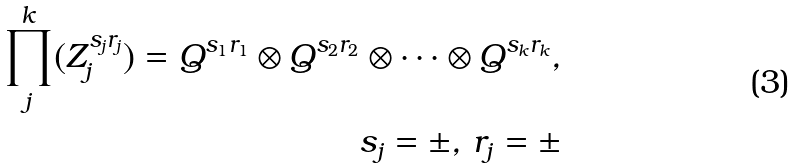Convert formula to latex. <formula><loc_0><loc_0><loc_500><loc_500>\prod ^ { k } _ { j } ( Z ^ { s _ { j } r _ { j } } _ { j } ) = Q ^ { s _ { 1 } r _ { 1 } } \otimes Q ^ { s _ { 2 } r _ { 2 } } \otimes \cdots \otimes Q ^ { s _ { k } r _ { k } } , \\ s _ { j } = \pm , \, r _ { j } = \pm</formula> 